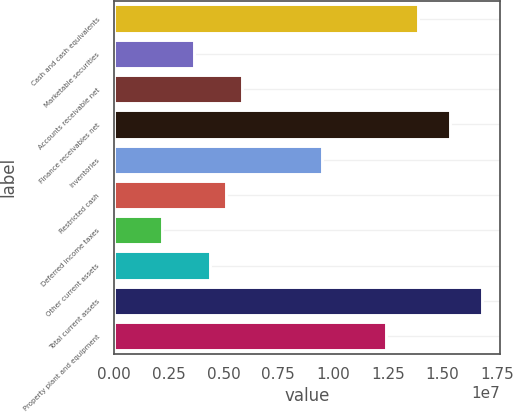<chart> <loc_0><loc_0><loc_500><loc_500><bar_chart><fcel>Cash and cash equivalents<fcel>Marketable securities<fcel>Accounts receivable net<fcel>Finance receivables net<fcel>Inventories<fcel>Restricted cash<fcel>Deferred income taxes<fcel>Other current assets<fcel>Total current assets<fcel>Property plant and equipment<nl><fcel>1.38791e+07<fcel>3.65492e+06<fcel>5.84582e+06<fcel>1.53397e+07<fcel>9.49733e+06<fcel>5.11552e+06<fcel>2.19432e+06<fcel>4.38522e+06<fcel>1.68003e+07<fcel>1.24185e+07<nl></chart> 